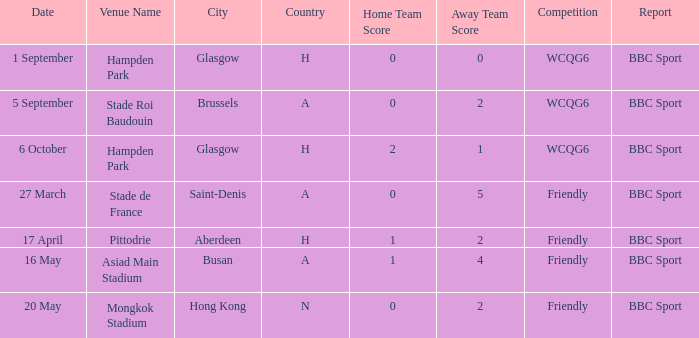Who reported the game on 6 october? BBC Sport. 